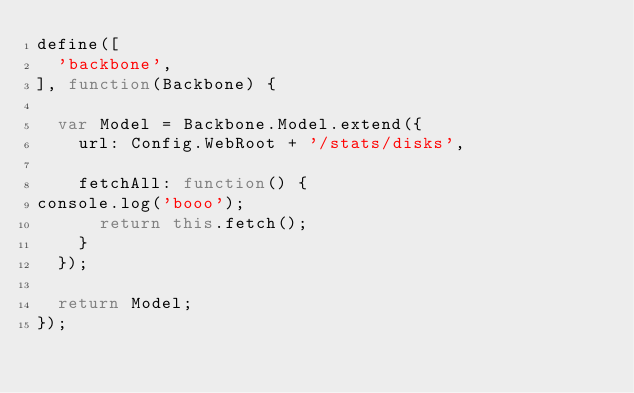Convert code to text. <code><loc_0><loc_0><loc_500><loc_500><_JavaScript_>define([
	'backbone',
], function(Backbone) {

	var Model = Backbone.Model.extend({
		url: Config.WebRoot + '/stats/disks',

		fetchAll: function() {
console.log('booo');
			return this.fetch();
		}
	});

	return Model;
});</code> 